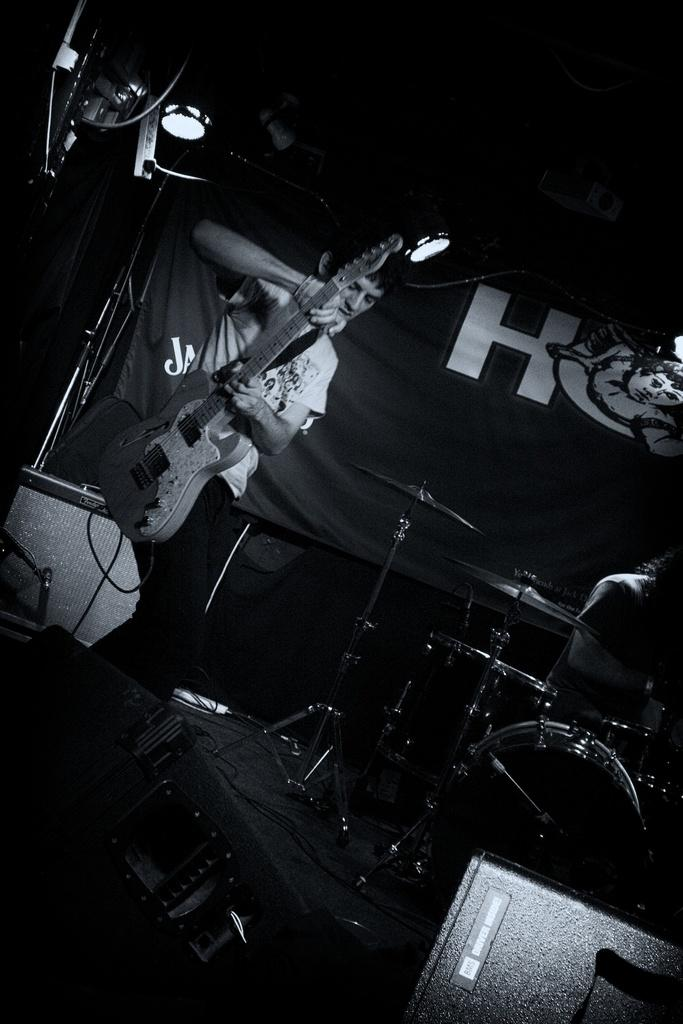What is the man in the center of the image holding? The man is holding a guitar in the center of the image. What else can be seen around the man? There are musical instruments around the man. Can you describe the person sitting on the right side of the image? There is a person sitting on the right side of the image. What type of pencil is the snake using to write music in the image? There is no snake or pencil present in the image. What are the acoustics like in the room where the image was taken? The provided facts do not give any information about the acoustics in the room where the image was taken. 